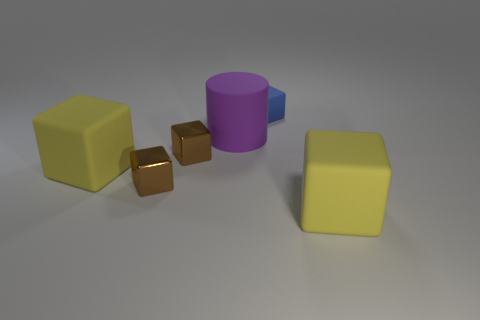How many brown blocks must be subtracted to get 1 brown blocks? 1 Subtract all large cubes. How many cubes are left? 3 Add 2 blue cubes. How many objects exist? 8 Subtract all yellow blocks. How many blocks are left? 3 Subtract all large rubber cubes. Subtract all large purple cylinders. How many objects are left? 3 Add 2 big purple rubber cylinders. How many big purple rubber cylinders are left? 3 Add 2 big gray metal things. How many big gray metal things exist? 2 Subtract 0 green cylinders. How many objects are left? 6 Subtract all cylinders. How many objects are left? 5 Subtract 1 cylinders. How many cylinders are left? 0 